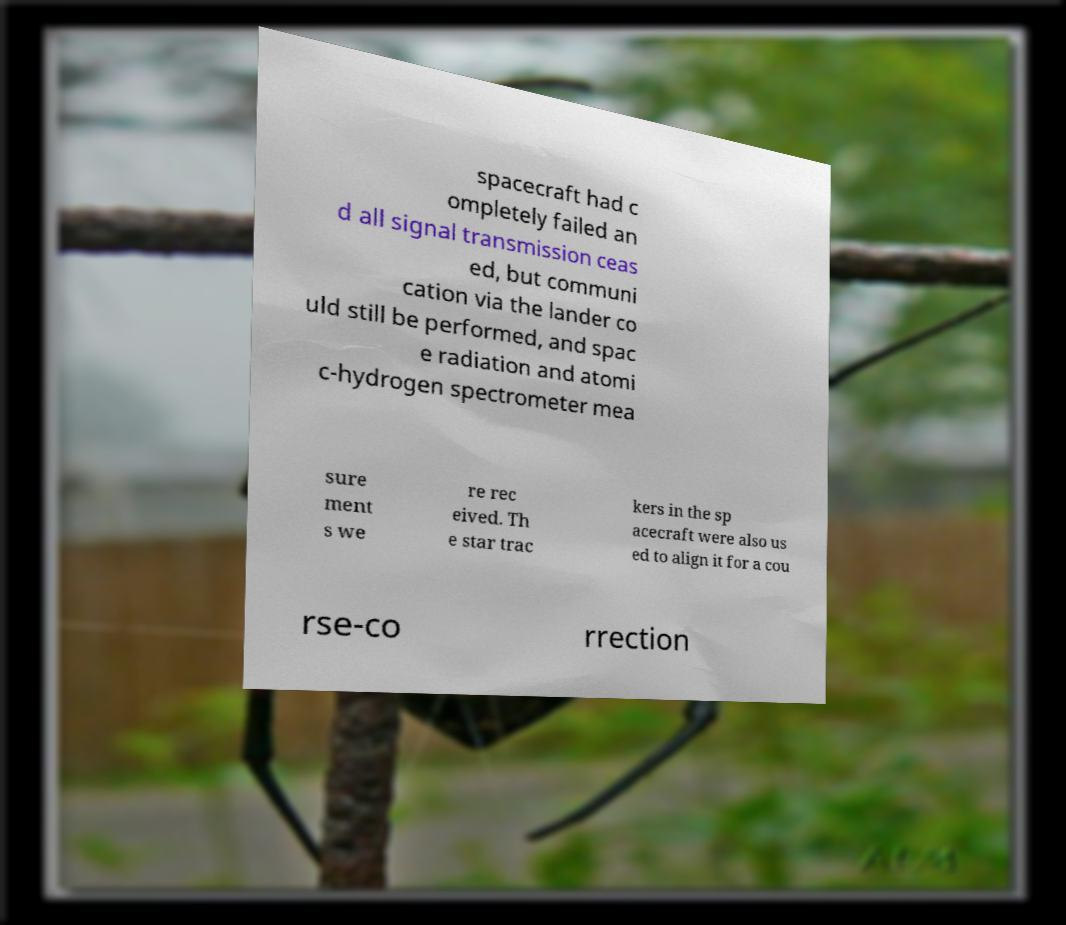I need the written content from this picture converted into text. Can you do that? spacecraft had c ompletely failed an d all signal transmission ceas ed, but communi cation via the lander co uld still be performed, and spac e radiation and atomi c-hydrogen spectrometer mea sure ment s we re rec eived. Th e star trac kers in the sp acecraft were also us ed to align it for a cou rse-co rrection 